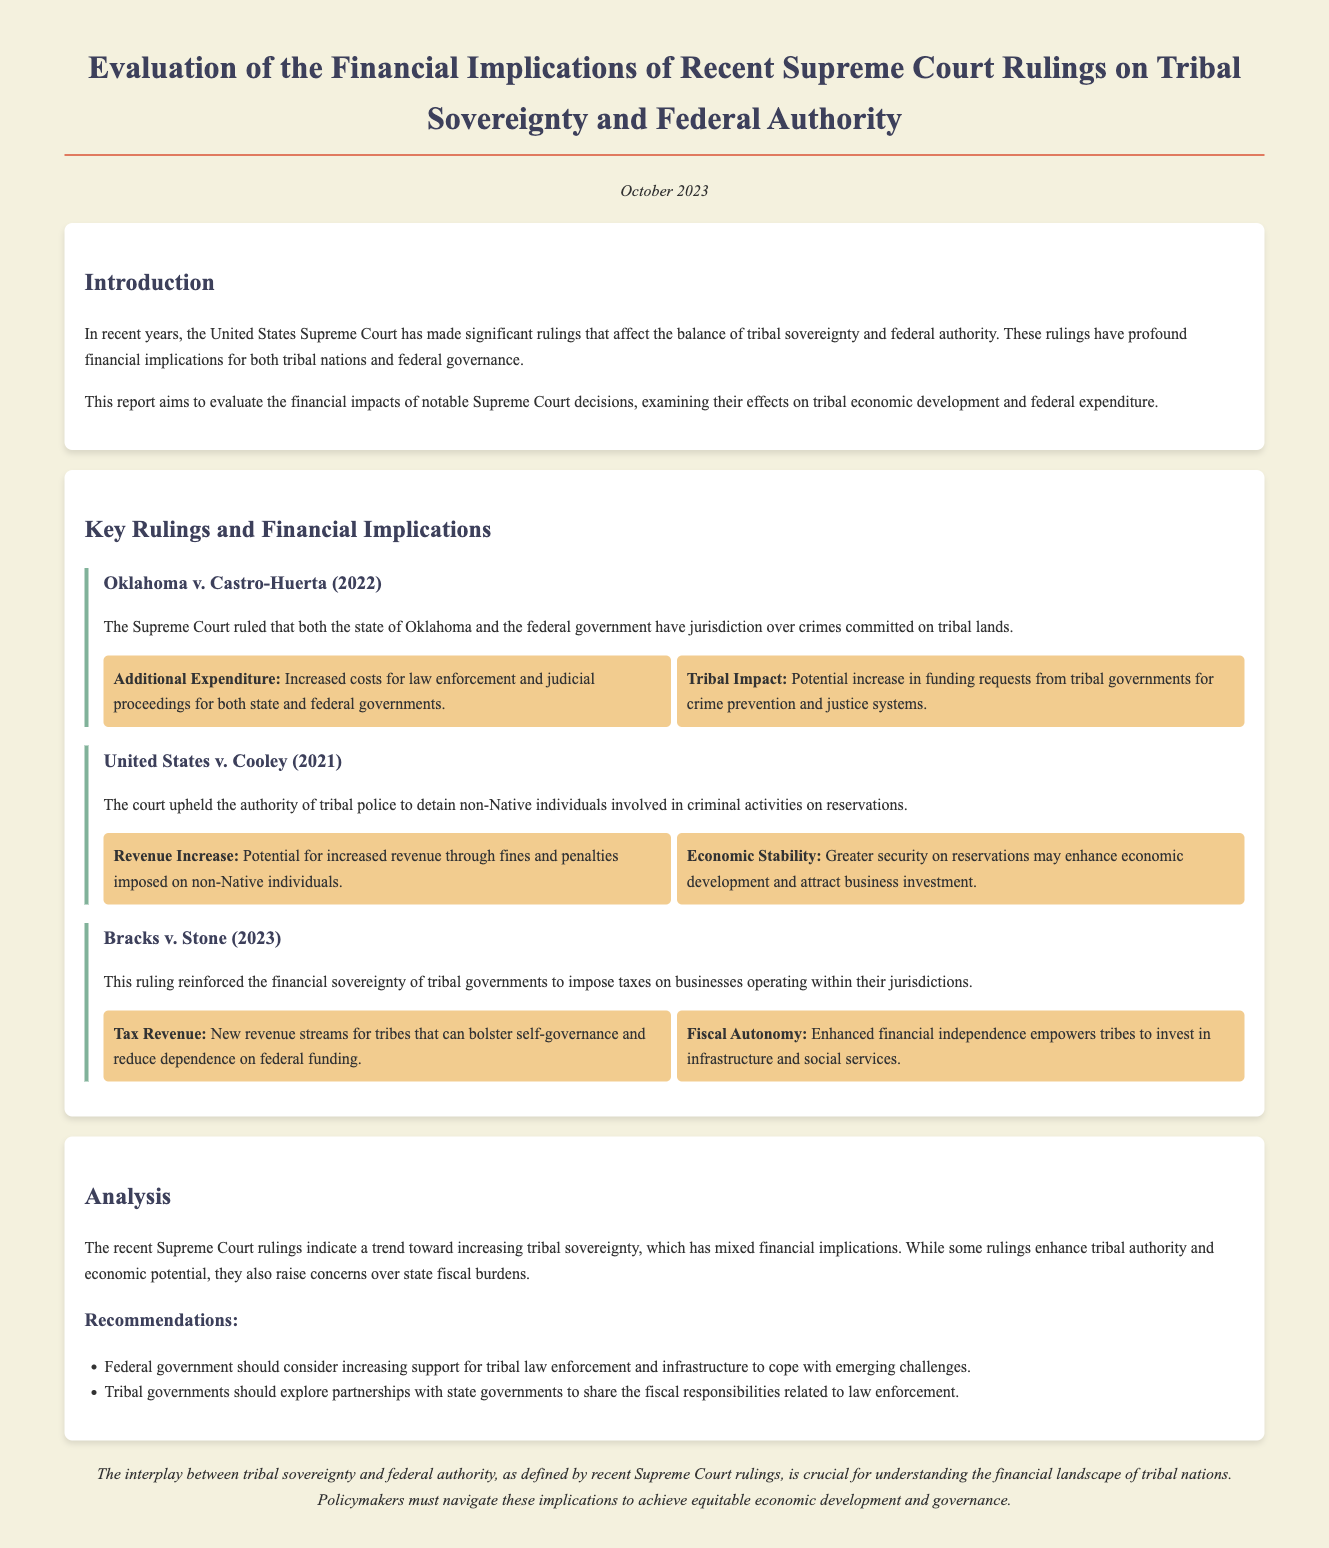What case was ruled on in 2022? The case ruled on in 2022 is mentioned under "Oklahoma v. Castro-Huerta".
Answer: Oklahoma v. Castro-Huerta What year did the Supreme Court uphold the authority of tribal police? This information is provided under the case "United States v. Cooley," which states the ruling occurred in 2021.
Answer: 2021 What type of revenue streams are mentioned in the "Bracks v. Stone" case? The report details new tax revenue streams from the ruling which emphasizes financial sovereignty.
Answer: Tax Revenue What is one implication of the "United States v. Cooley" case? The document states that there may be greater security on reservations, which could enhance economic development.
Answer: Greater security What is the date of the report? The date of the report is prominently displayed under the title as October 2023.
Answer: October 2023 What was the focus of the recommendations section? The recommendations section emphasizes increasing support for tribal law enforcement and exploring partnerships with state governments.
Answer: Support for tribal law enforcement What was the overall conclusion regarding tribal sovereignty and federal authority? The conclusion notes the importance of navigating the implications for equitable economic development and governance.
Answer: Equitable economic development What is mentioned as a concern due to some rulings? The document discusses concerns over state fiscal burdens due to increasing tribal sovereignty.
Answer: State fiscal burdens 